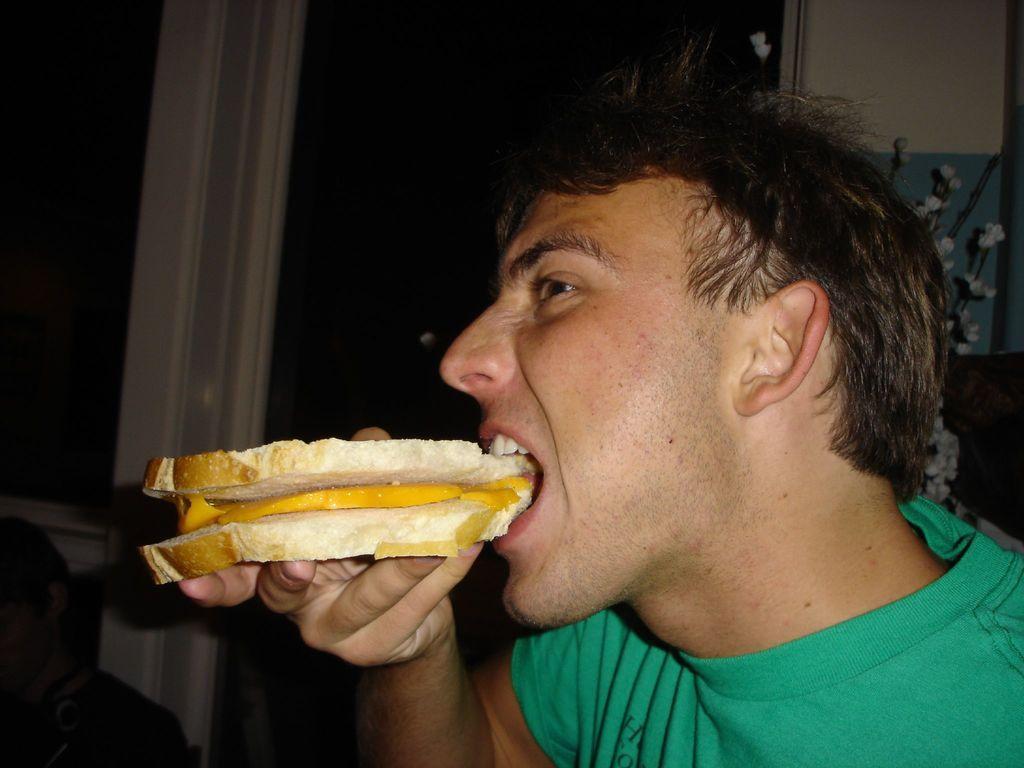How would you summarize this image in a sentence or two? In the center of the image we can see person eating bread. In the background we can see windows. 